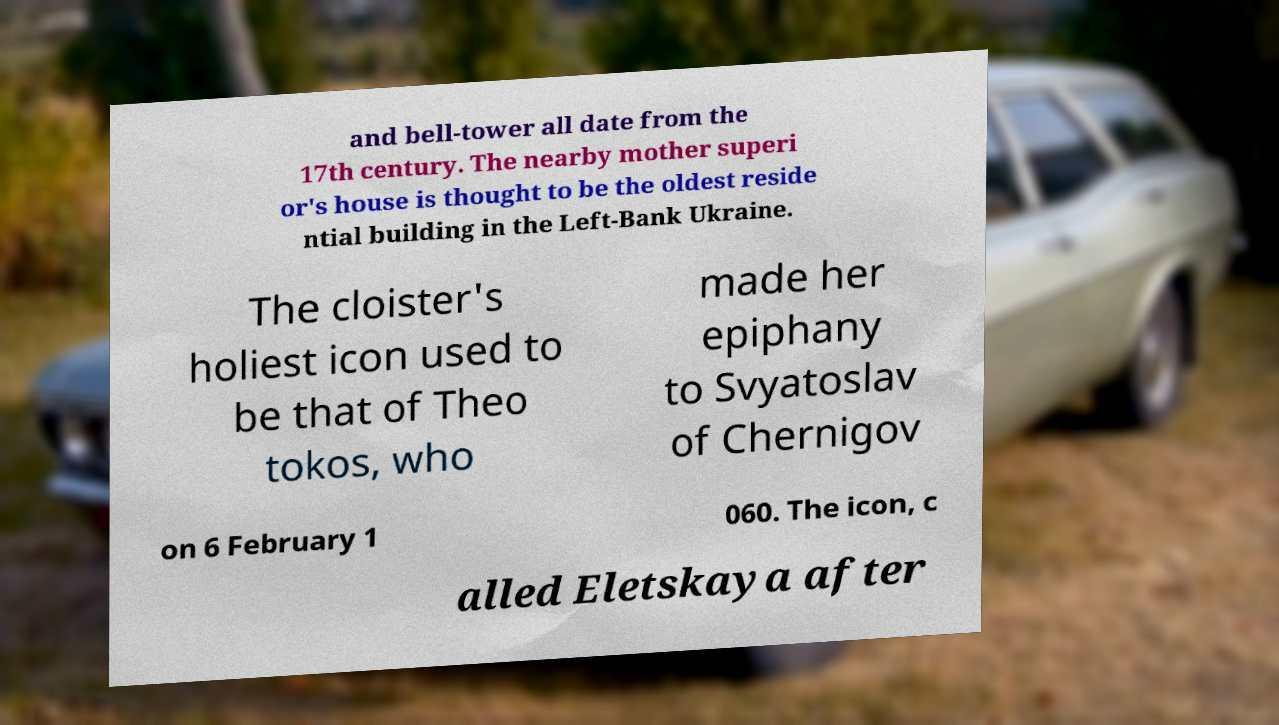I need the written content from this picture converted into text. Can you do that? and bell-tower all date from the 17th century. The nearby mother superi or's house is thought to be the oldest reside ntial building in the Left-Bank Ukraine. The cloister's holiest icon used to be that of Theo tokos, who made her epiphany to Svyatoslav of Chernigov on 6 February 1 060. The icon, c alled Eletskaya after 